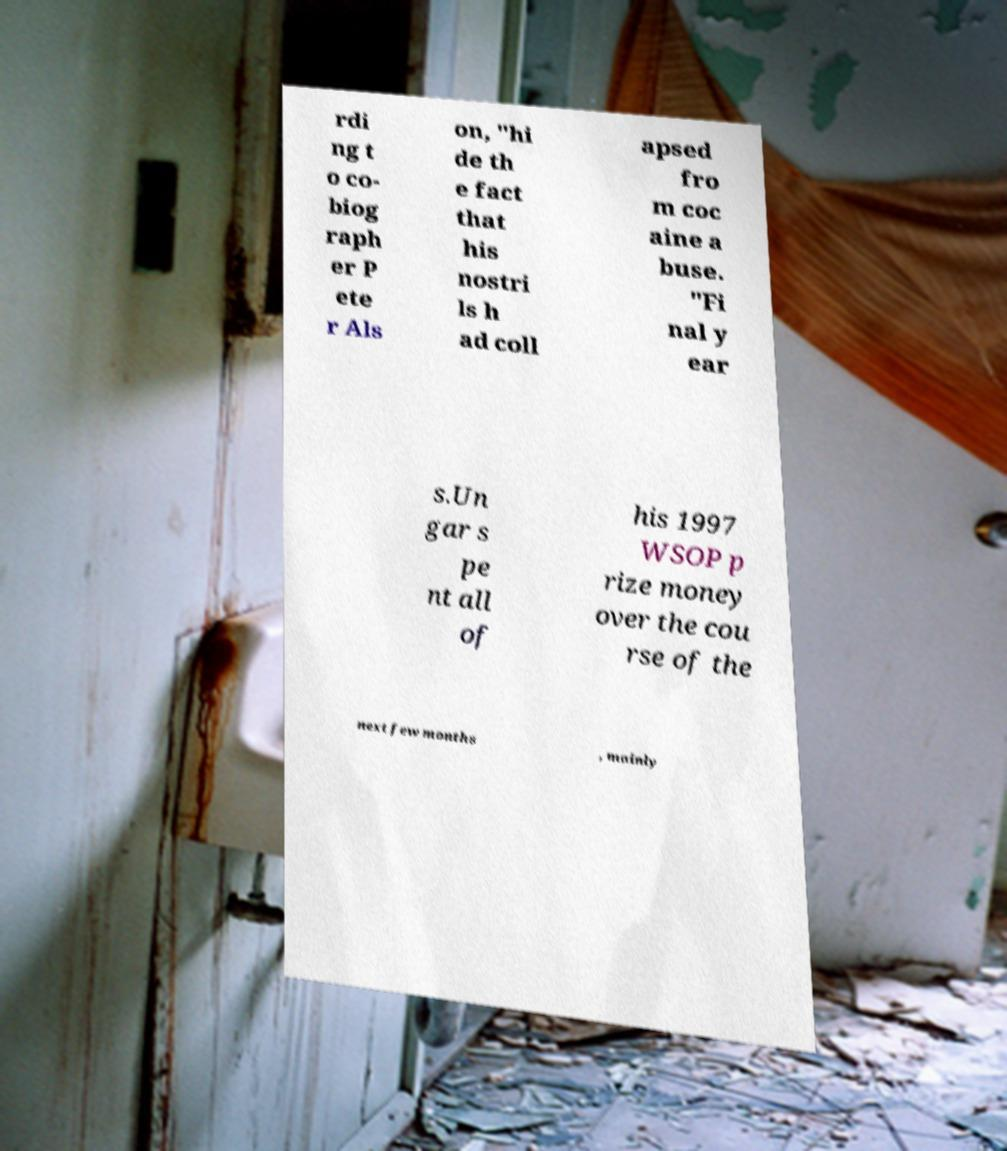Can you accurately transcribe the text from the provided image for me? rdi ng t o co- biog raph er P ete r Als on, "hi de th e fact that his nostri ls h ad coll apsed fro m coc aine a buse. "Fi nal y ear s.Un gar s pe nt all of his 1997 WSOP p rize money over the cou rse of the next few months , mainly 